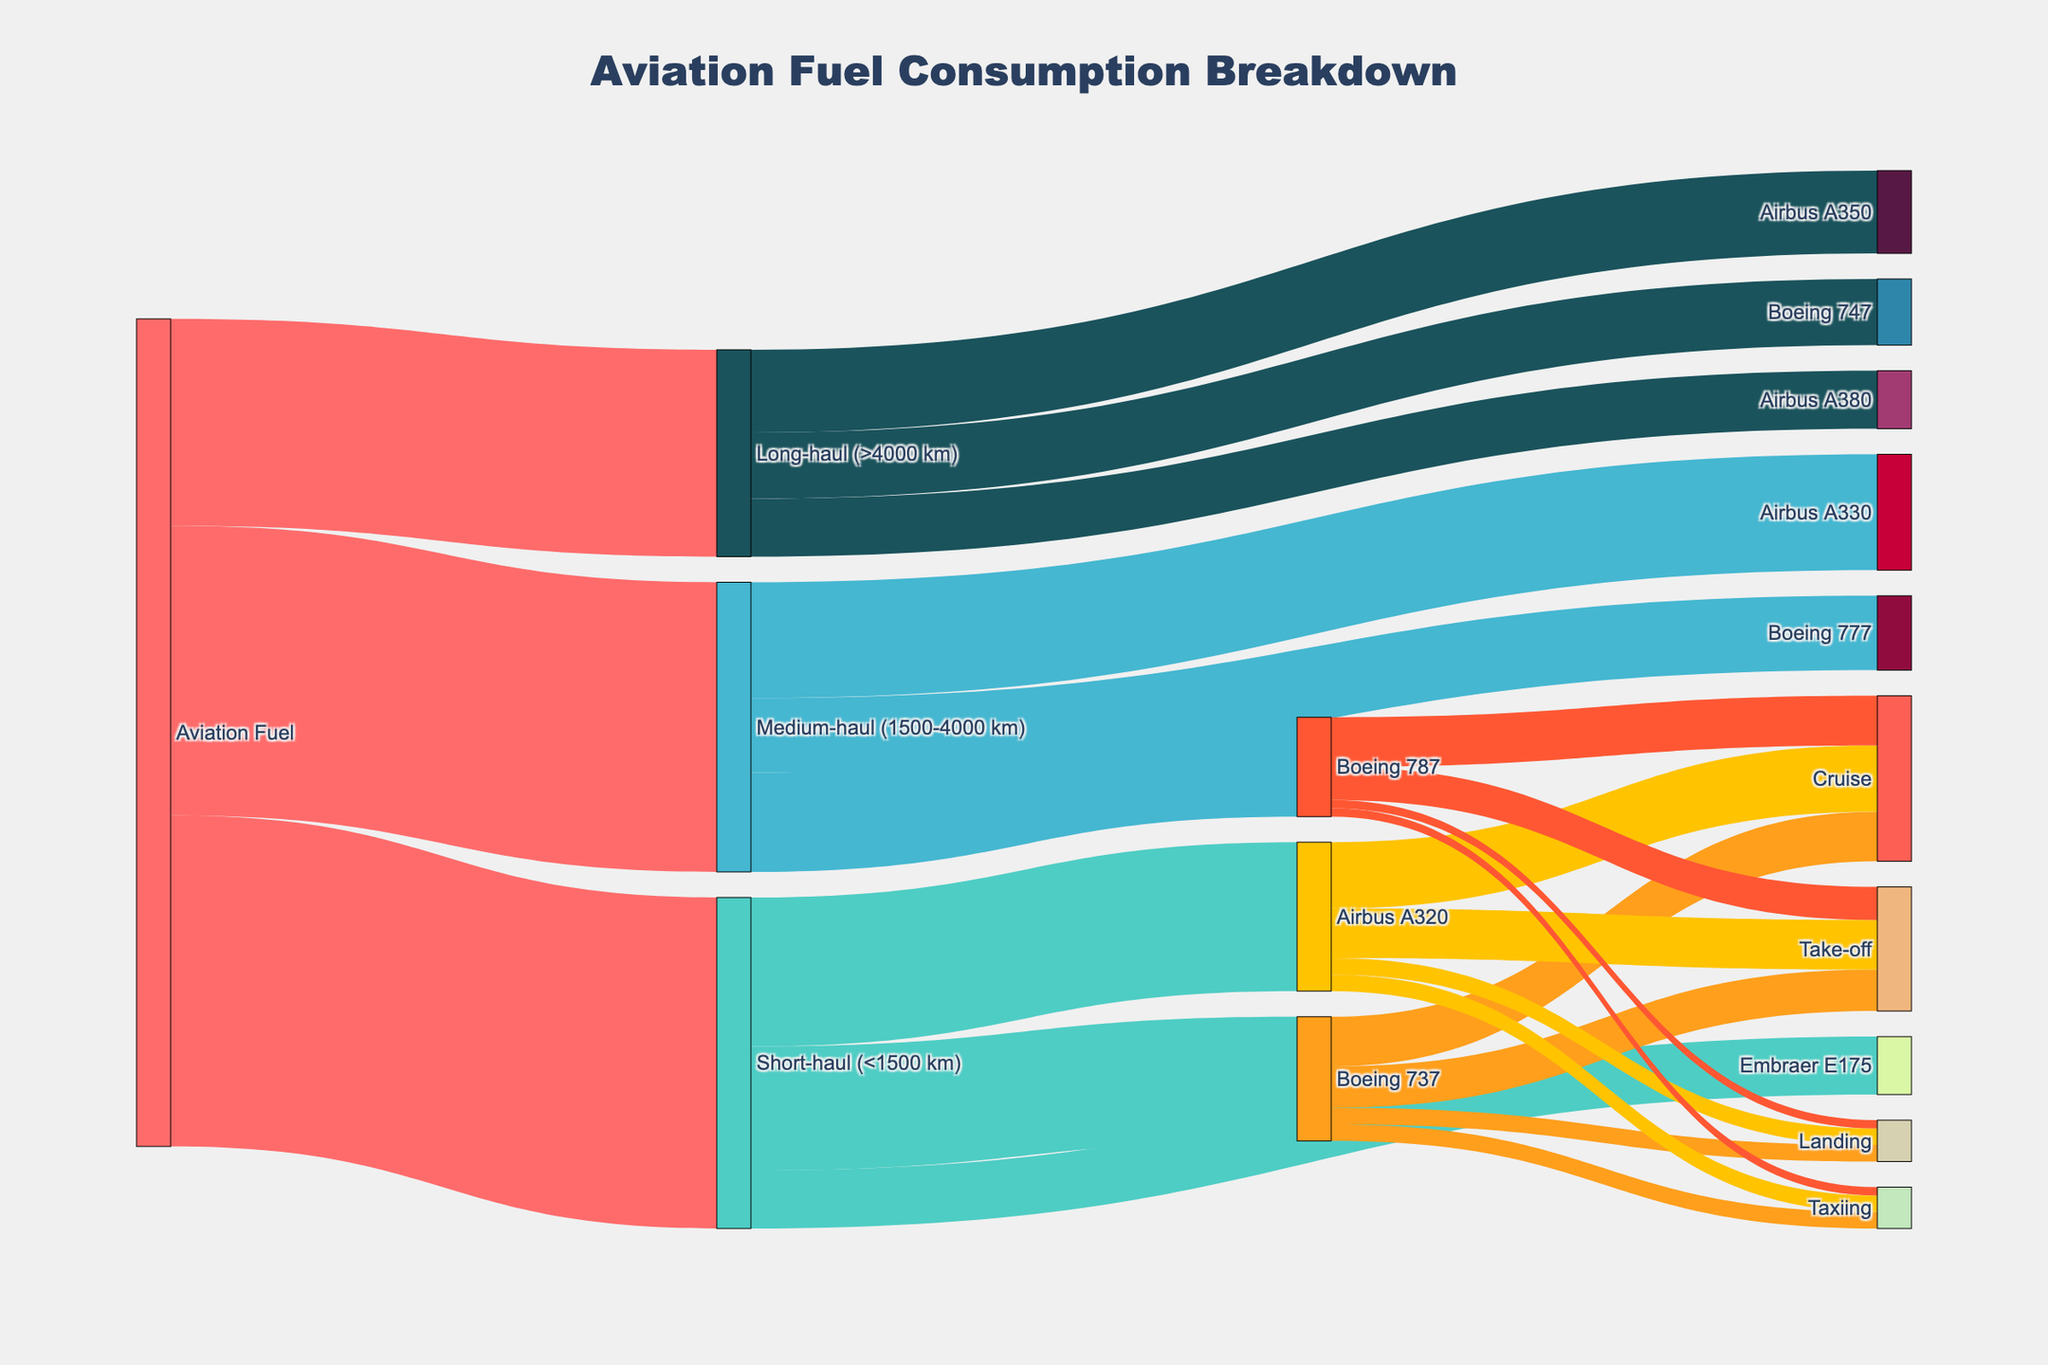What is the title of the Sankey Diagram? The title of the Sankey Diagram is placed at the top center of the plot, which denotes the overall topic and helps the viewer understand what is being represented.
Answer: Aviation Fuel Consumption Breakdown How much aviation fuel is consumed by short-haul flights? To find this, look at the flow from "Aviation Fuel" to "Short-haul (<1500 km)" and check the value associated with it.
Answer: 40 Which aircraft consumes the most aviation fuel in the medium-haul category? In the medium-haul category, compare the values for each aircraft: Boeing 787 (12), Airbus A330 (14), Boeing 777 (9). The Airbus A330 has the highest value.
Answer: Airbus A330 What is the combined fuel consumption for long-haul flights? Add the values associated with long-haul flights: Airbus A350 (10), Boeing 747 (8), Airbus A380 (7). The sum is 10 + 8 + 7 = 25.
Answer: 25 How much fuel does the Airbus A320 consume for take-off? Look at the link from "Airbus A320" to "Take-off" and check the value. This value represents the fuel consumption for take-off for the Airbus A320.
Answer: 6 Which aircraft consumes the least fuel in the short-haul category? Compare the fuel consumptions of Boeing 737 (15), Airbus A320 (18), Embraer E175 (7) in the short-haul category. The Embraer E175 consumes the least fuel.
Answer: Embraer E175 What is the total aviation fuel consumed by Boeing aircraft (Boeing 737, 787, 777, 747)? Sum the values for each Boeing aircraft: Boeing 737 (15), Boeing 787 (12), Boeing 777 (9), Boeing 747 (8). The total is 15 + 12 + 9 + 8 = 44.
Answer: 44 Which phase of flight uses the most fuel for the Boeing 737? Compare the values for the Boeing 737 phases: Taxiing (2), Take-off (5), Cruise (6), Landing (2). The Cruise phase consumes the most fuel.
Answer: Cruise How much fuel is consumed during take-off for both the short-haul and medium-haul categories combined? Sum the take-off values for all aircraft in these categories: Boeing 737 (5) + Airbus A320 (6) + Boeing 787 (4) = 5 + 6 + 4 = 15.
Answer: 15 What colors are used for representing the Short-haul, Medium-haul, and Long-haul categories? Identify the colors used in the Sankey Diagram for these nodes: Short-haul (green), Medium-haul (blue), Long-haul (dark blue).
Answer: Green, Blue, Dark Blue 